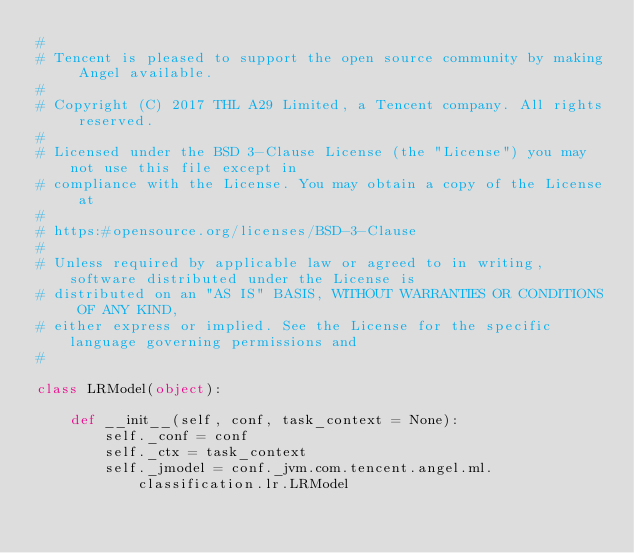Convert code to text. <code><loc_0><loc_0><loc_500><loc_500><_Python_>#
# Tencent is pleased to support the open source community by making Angel available.
#
# Copyright (C) 2017 THL A29 Limited, a Tencent company. All rights reserved.
#
# Licensed under the BSD 3-Clause License (the "License") you may not use this file except in
# compliance with the License. You may obtain a copy of the License at
#
# https:#opensource.org/licenses/BSD-3-Clause
#
# Unless required by applicable law or agreed to in writing, software distributed under the License is
# distributed on an "AS IS" BASIS, WITHOUT WARRANTIES OR CONDITIONS OF ANY KIND,
# either express or implied. See the License for the specific language governing permissions and
#

class LRModel(object):

    def __init__(self, conf, task_context = None):
        self._conf = conf
        self._ctx = task_context
        self._jmodel = conf._jvm.com.tencent.angel.ml.classification.lr.LRModel



</code> 